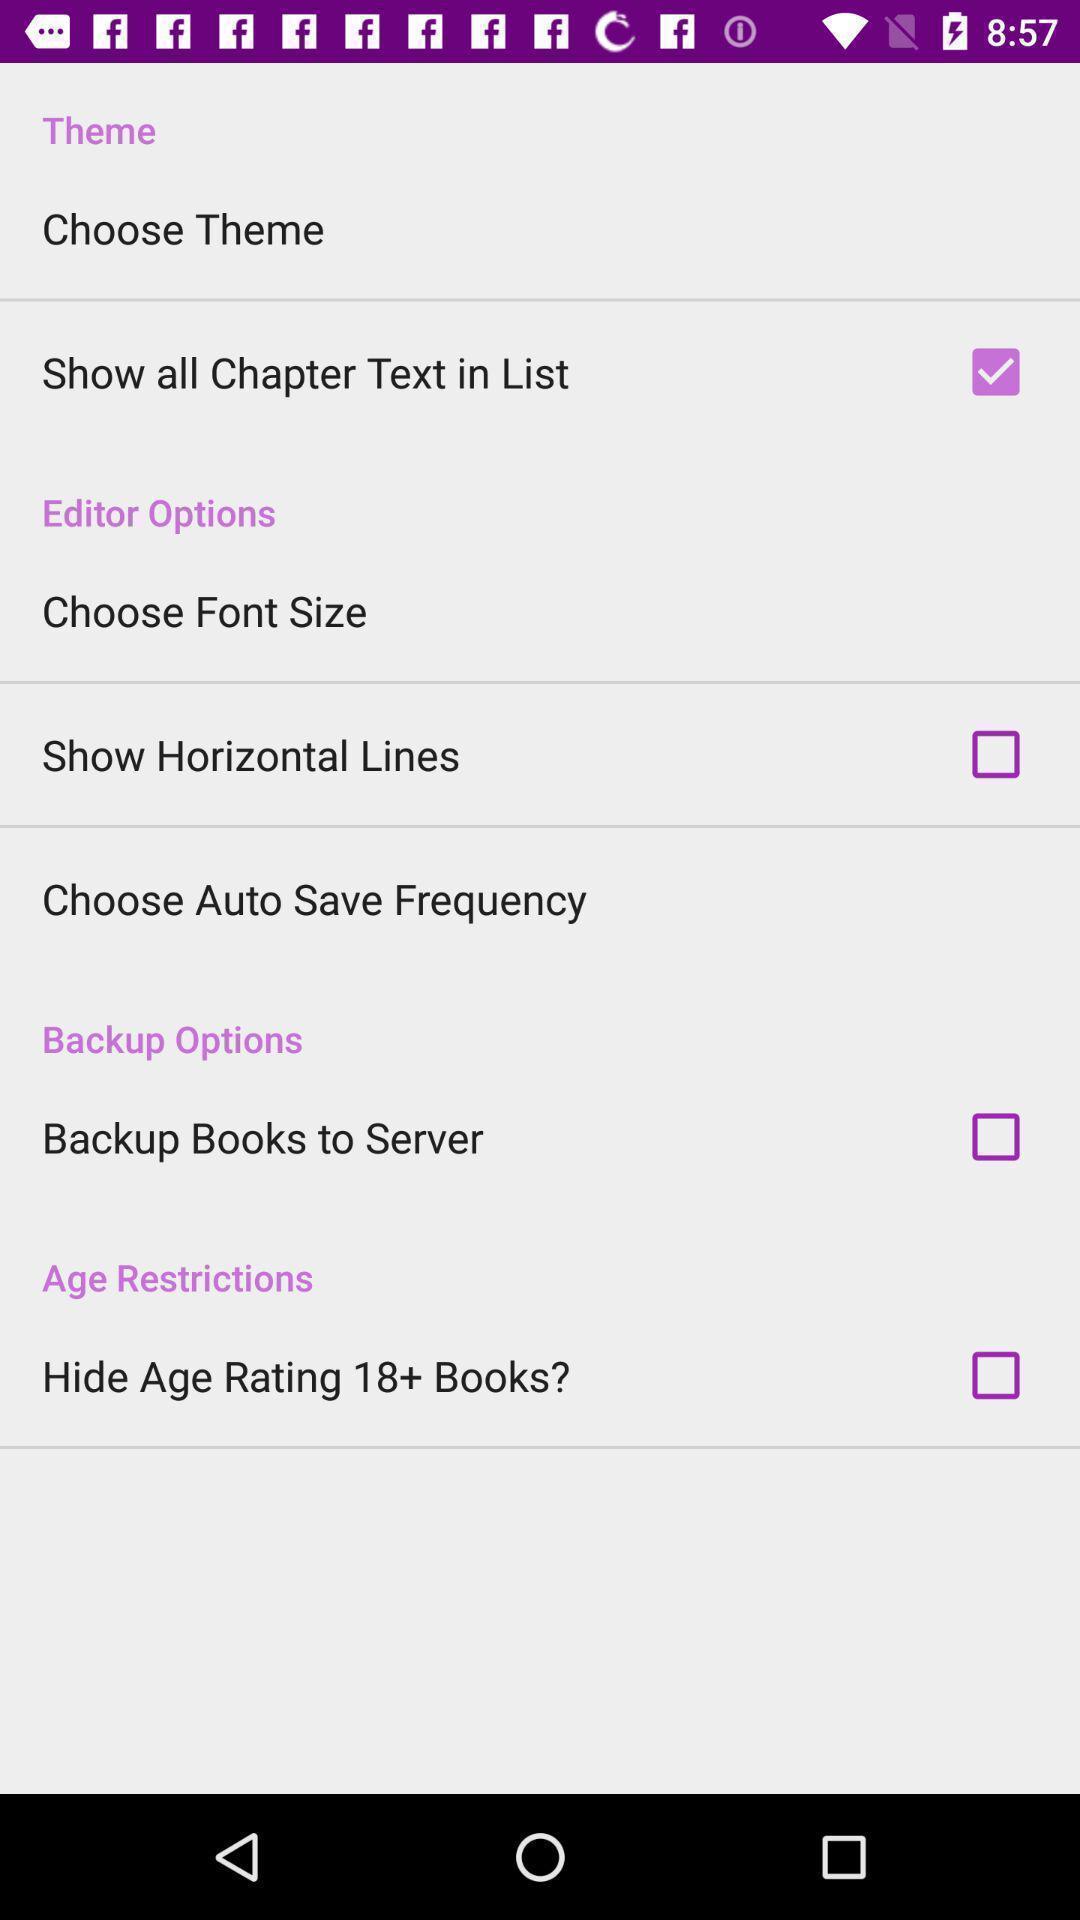What is the overall content of this screenshot? Various options in a story reading app. 